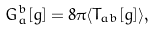<formula> <loc_0><loc_0><loc_500><loc_500>G _ { a } ^ { b } [ g ] = 8 \pi \langle T _ { a b } [ g ] \rangle ,</formula> 